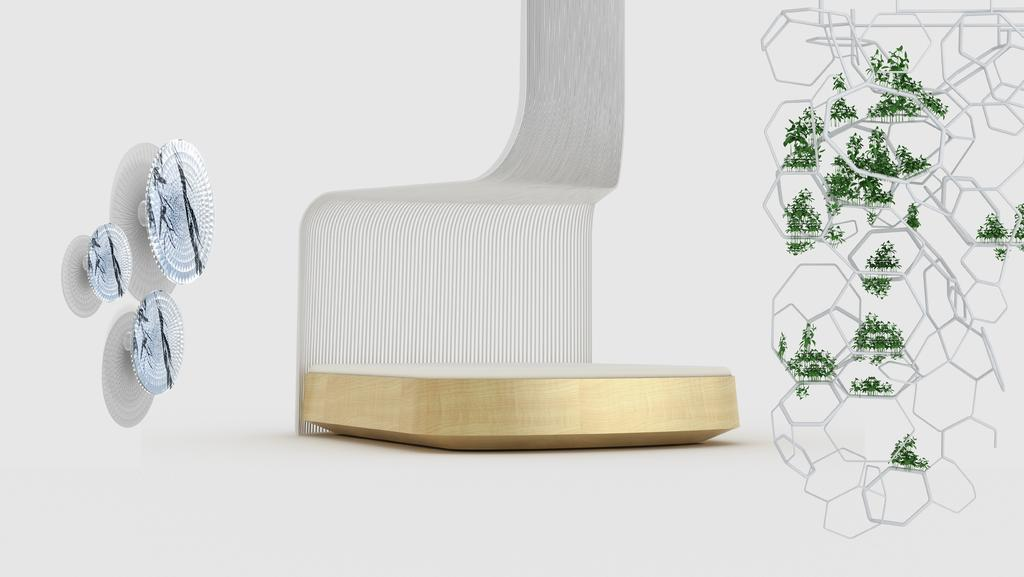How has the image been altered or modified? The image has been edited. What color can be seen in the image? There are red elements in the image. What type of natural elements are present in the image? There are leaves in the image. What can be found in the image besides the red elements and leaves? There are objects in the image. What color is the background of the image? The background of the image is white. How many eggs are visible in the image? There are no eggs present in the image. What type of stamp can be seen on the red elements in the image? There is no stamp present on the red elements in the image. 